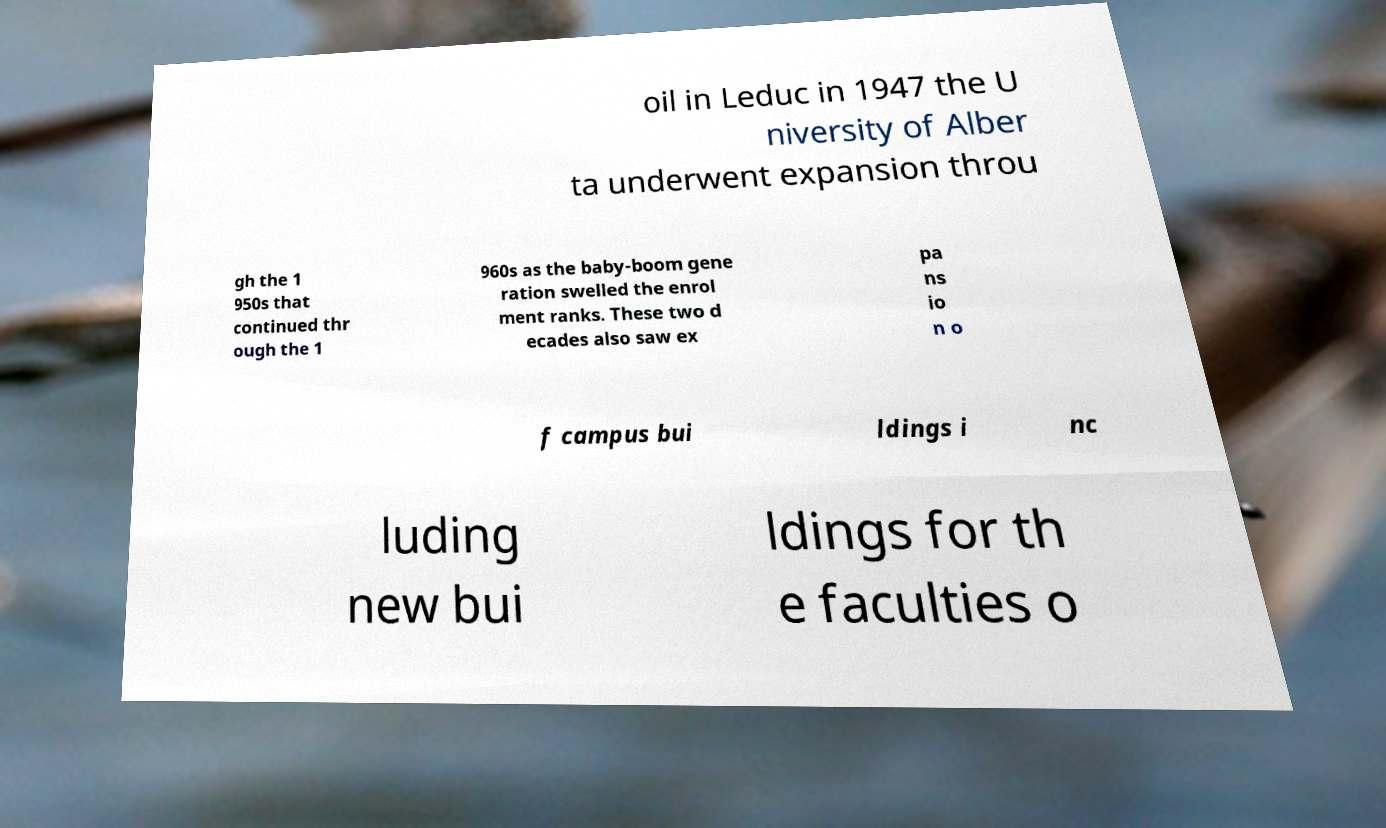Can you read and provide the text displayed in the image?This photo seems to have some interesting text. Can you extract and type it out for me? oil in Leduc in 1947 the U niversity of Alber ta underwent expansion throu gh the 1 950s that continued thr ough the 1 960s as the baby-boom gene ration swelled the enrol ment ranks. These two d ecades also saw ex pa ns io n o f campus bui ldings i nc luding new bui ldings for th e faculties o 